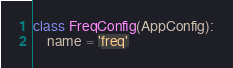Convert code to text. <code><loc_0><loc_0><loc_500><loc_500><_Python_>

class FreqConfig(AppConfig):
    name = 'freq'
</code> 